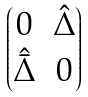Convert formula to latex. <formula><loc_0><loc_0><loc_500><loc_500>\begin{pmatrix} 0 & \hat { \Delta } \\ \hat { \bar { \Delta } } & 0 \end{pmatrix}</formula> 